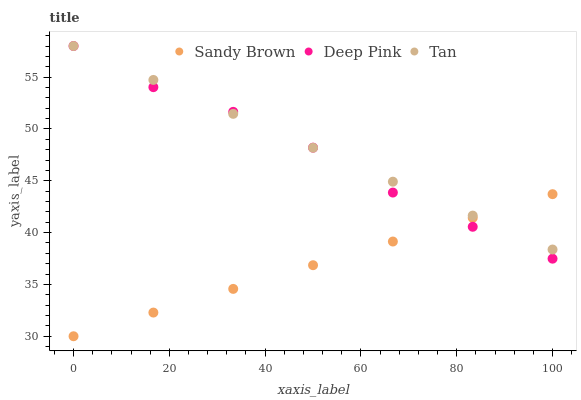Does Sandy Brown have the minimum area under the curve?
Answer yes or no. Yes. Does Tan have the maximum area under the curve?
Answer yes or no. Yes. Does Deep Pink have the minimum area under the curve?
Answer yes or no. No. Does Deep Pink have the maximum area under the curve?
Answer yes or no. No. Is Tan the smoothest?
Answer yes or no. Yes. Is Deep Pink the roughest?
Answer yes or no. Yes. Is Sandy Brown the smoothest?
Answer yes or no. No. Is Sandy Brown the roughest?
Answer yes or no. No. Does Sandy Brown have the lowest value?
Answer yes or no. Yes. Does Deep Pink have the lowest value?
Answer yes or no. No. Does Deep Pink have the highest value?
Answer yes or no. Yes. Does Sandy Brown have the highest value?
Answer yes or no. No. Does Tan intersect Deep Pink?
Answer yes or no. Yes. Is Tan less than Deep Pink?
Answer yes or no. No. Is Tan greater than Deep Pink?
Answer yes or no. No. 